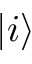<formula> <loc_0><loc_0><loc_500><loc_500>| i \rangle</formula> 